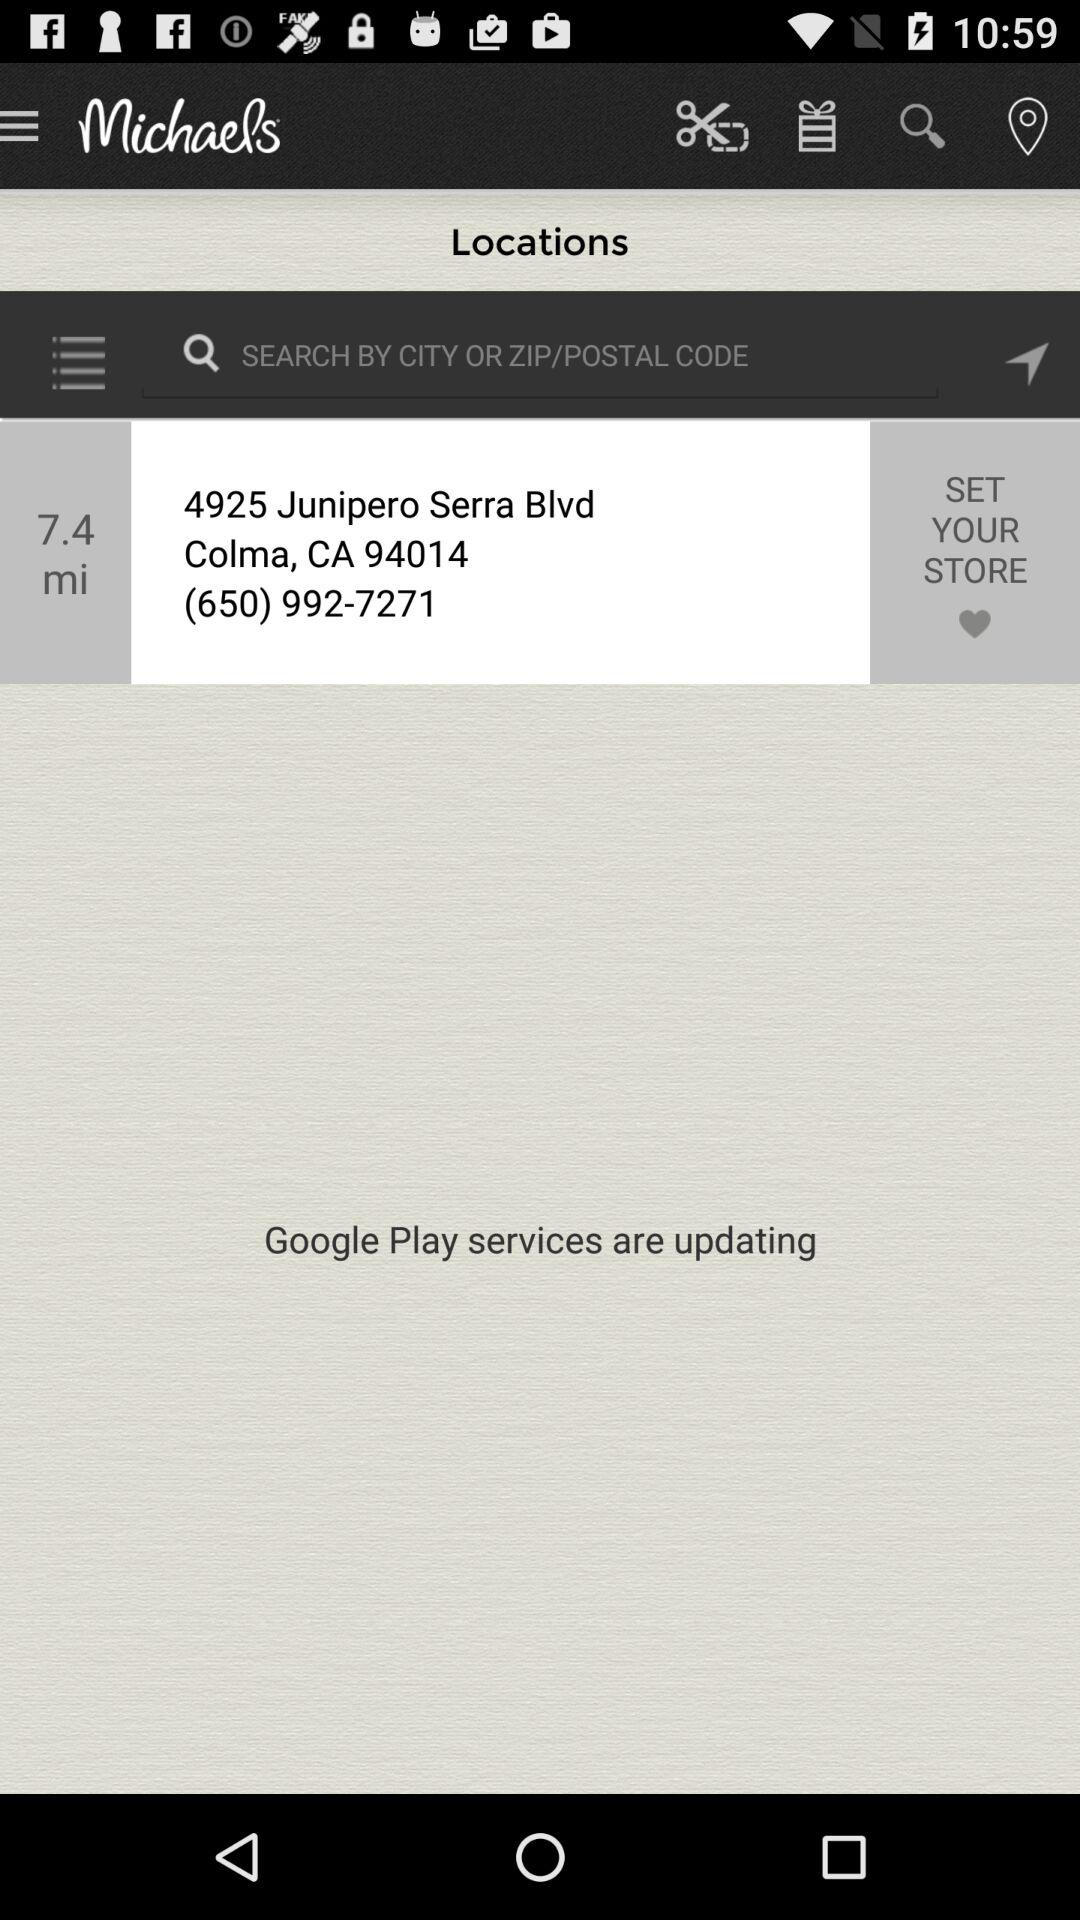How many miles away is the store?
Answer the question using a single word or phrase. 7.4 mi 